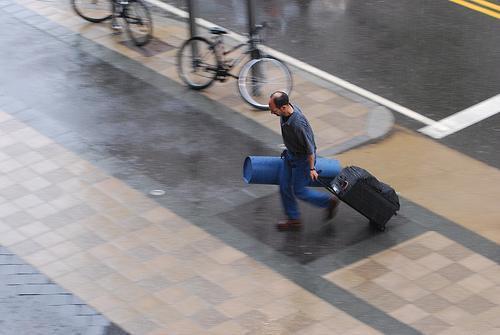How many people are in the picture?
Give a very brief answer. 1. 